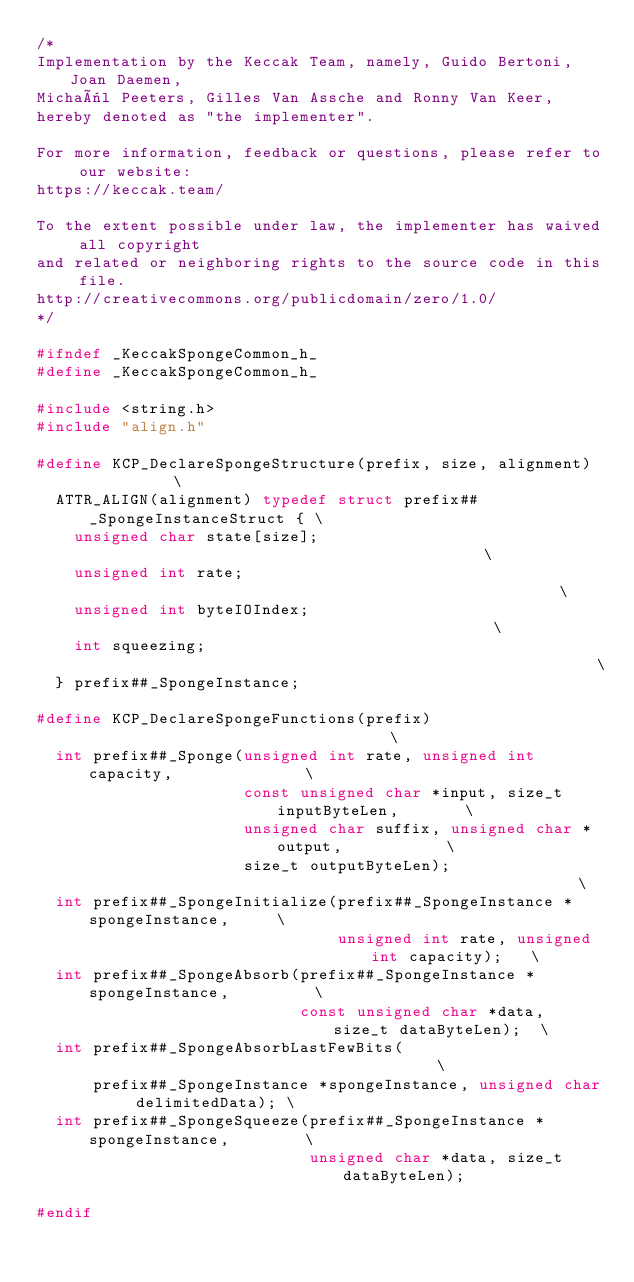<code> <loc_0><loc_0><loc_500><loc_500><_C_>/*
Implementation by the Keccak Team, namely, Guido Bertoni, Joan Daemen,
Michaël Peeters, Gilles Van Assche and Ronny Van Keer,
hereby denoted as "the implementer".

For more information, feedback or questions, please refer to our website:
https://keccak.team/

To the extent possible under law, the implementer has waived all copyright
and related or neighboring rights to the source code in this file.
http://creativecommons.org/publicdomain/zero/1.0/
*/

#ifndef _KeccakSpongeCommon_h_
#define _KeccakSpongeCommon_h_

#include <string.h>
#include "align.h"

#define KCP_DeclareSpongeStructure(prefix, size, alignment)            \
  ATTR_ALIGN(alignment) typedef struct prefix##_SpongeInstanceStruct { \
    unsigned char state[size];                                         \
    unsigned int rate;                                                 \
    unsigned int byteIOIndex;                                          \
    int squeezing;                                                     \
  } prefix##_SpongeInstance;

#define KCP_DeclareSpongeFunctions(prefix)                                   \
  int prefix##_Sponge(unsigned int rate, unsigned int capacity,              \
                      const unsigned char *input, size_t inputByteLen,       \
                      unsigned char suffix, unsigned char *output,           \
                      size_t outputByteLen);                                 \
  int prefix##_SpongeInitialize(prefix##_SpongeInstance *spongeInstance,     \
                                unsigned int rate, unsigned int capacity);   \
  int prefix##_SpongeAbsorb(prefix##_SpongeInstance *spongeInstance,         \
                            const unsigned char *data, size_t dataByteLen);  \
  int prefix##_SpongeAbsorbLastFewBits(                                      \
      prefix##_SpongeInstance *spongeInstance, unsigned char delimitedData); \
  int prefix##_SpongeSqueeze(prefix##_SpongeInstance *spongeInstance,        \
                             unsigned char *data, size_t dataByteLen);

#endif
</code> 